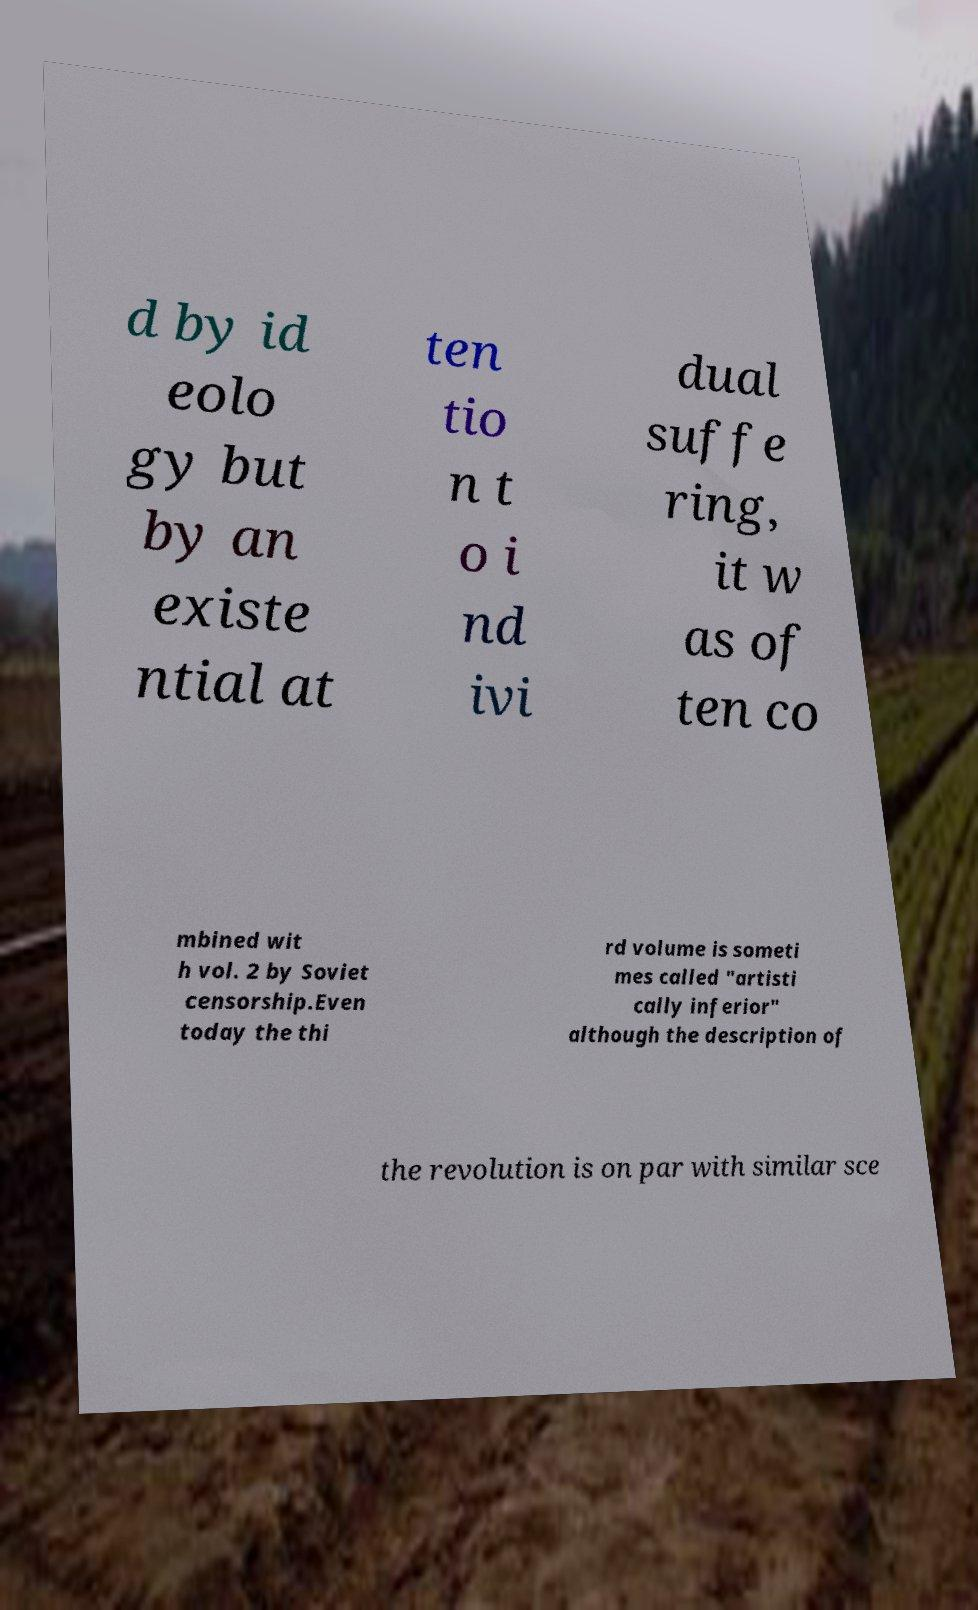What messages or text are displayed in this image? I need them in a readable, typed format. d by id eolo gy but by an existe ntial at ten tio n t o i nd ivi dual suffe ring, it w as of ten co mbined wit h vol. 2 by Soviet censorship.Even today the thi rd volume is someti mes called "artisti cally inferior" although the description of the revolution is on par with similar sce 